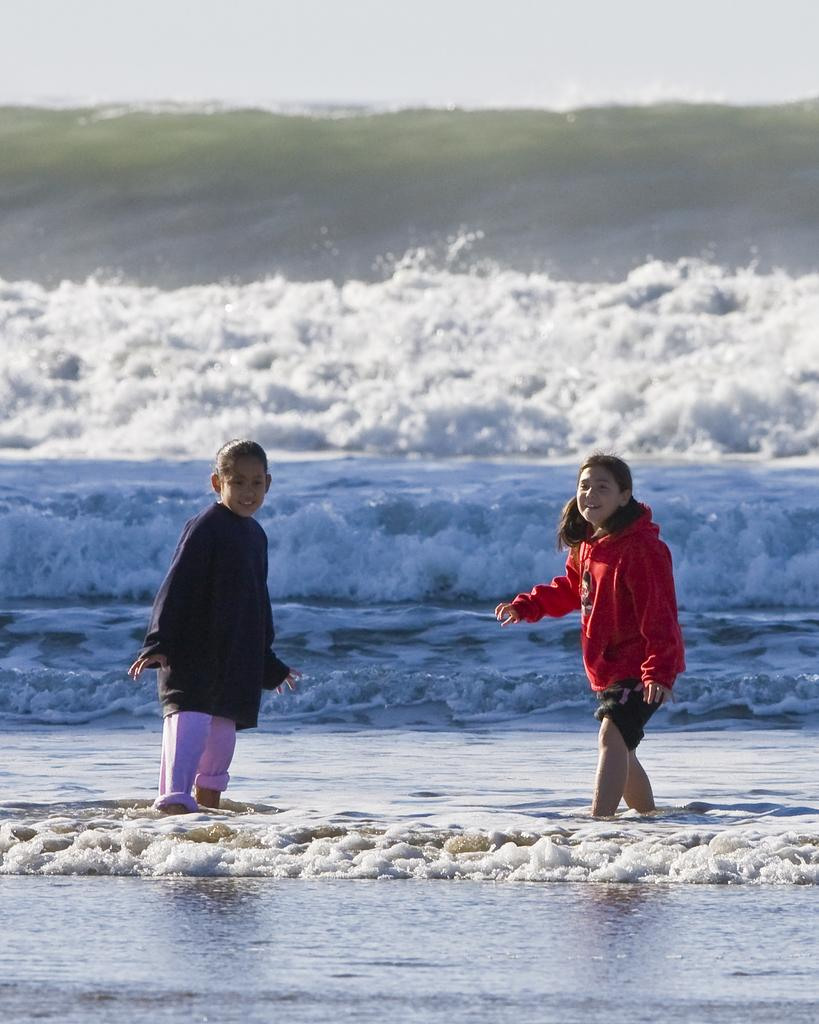What is the main setting of the picture? There is a beach in the picture. What are the two girls in the image doing? The two girls are playing in the water. What is the condition of the sky in the image? The sky is clear in the image. What type of oatmeal is being served at the beach in the image? There is no oatmeal present in the image; the girls are playing in the water. Can you see any corn growing on the beach in the image? There is no corn visible in the image; the focus is on the beach and the girls playing in the water. 